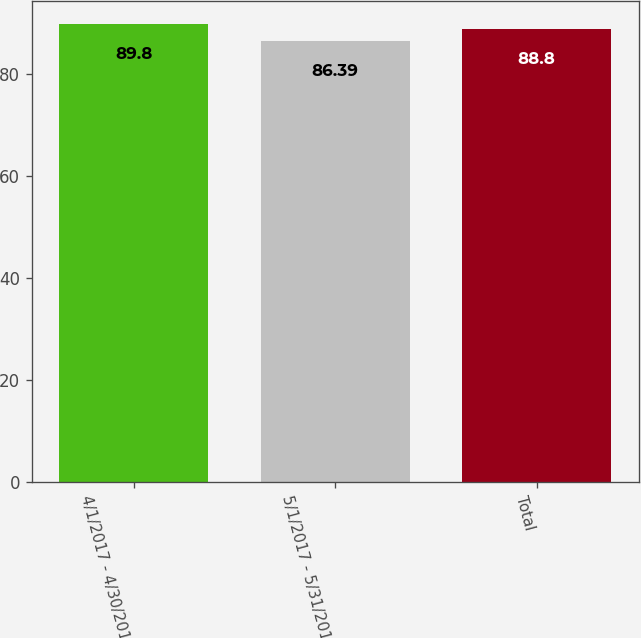Convert chart. <chart><loc_0><loc_0><loc_500><loc_500><bar_chart><fcel>4/1/2017 - 4/30/2017<fcel>5/1/2017 - 5/31/2017<fcel>Total<nl><fcel>89.8<fcel>86.39<fcel>88.8<nl></chart> 